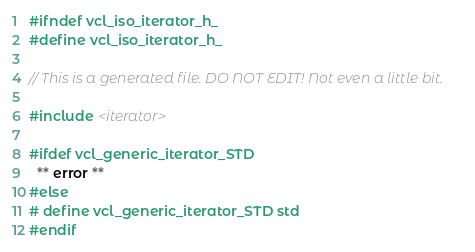<code> <loc_0><loc_0><loc_500><loc_500><_C_>#ifndef vcl_iso_iterator_h_
#define vcl_iso_iterator_h_

// This is a generated file. DO NOT EDIT! Not even a little bit.

#include <iterator>

#ifdef vcl_generic_iterator_STD
  ** error **
#else
# define vcl_generic_iterator_STD std
#endif
</code> 